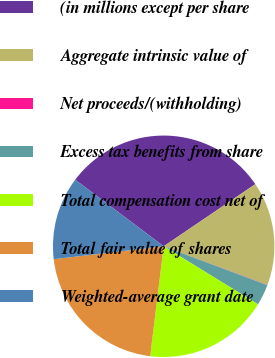<chart> <loc_0><loc_0><loc_500><loc_500><pie_chart><fcel>(in millions except per share<fcel>Aggregate intrinsic value of<fcel>Net proceeds/(withholding)<fcel>Excess tax benefits from share<fcel>Total compensation cost net of<fcel>Total fair value of shares<fcel>Weighted-average grant date<nl><fcel>30.25%<fcel>15.15%<fcel>0.04%<fcel>3.07%<fcel>18.17%<fcel>21.19%<fcel>12.13%<nl></chart> 